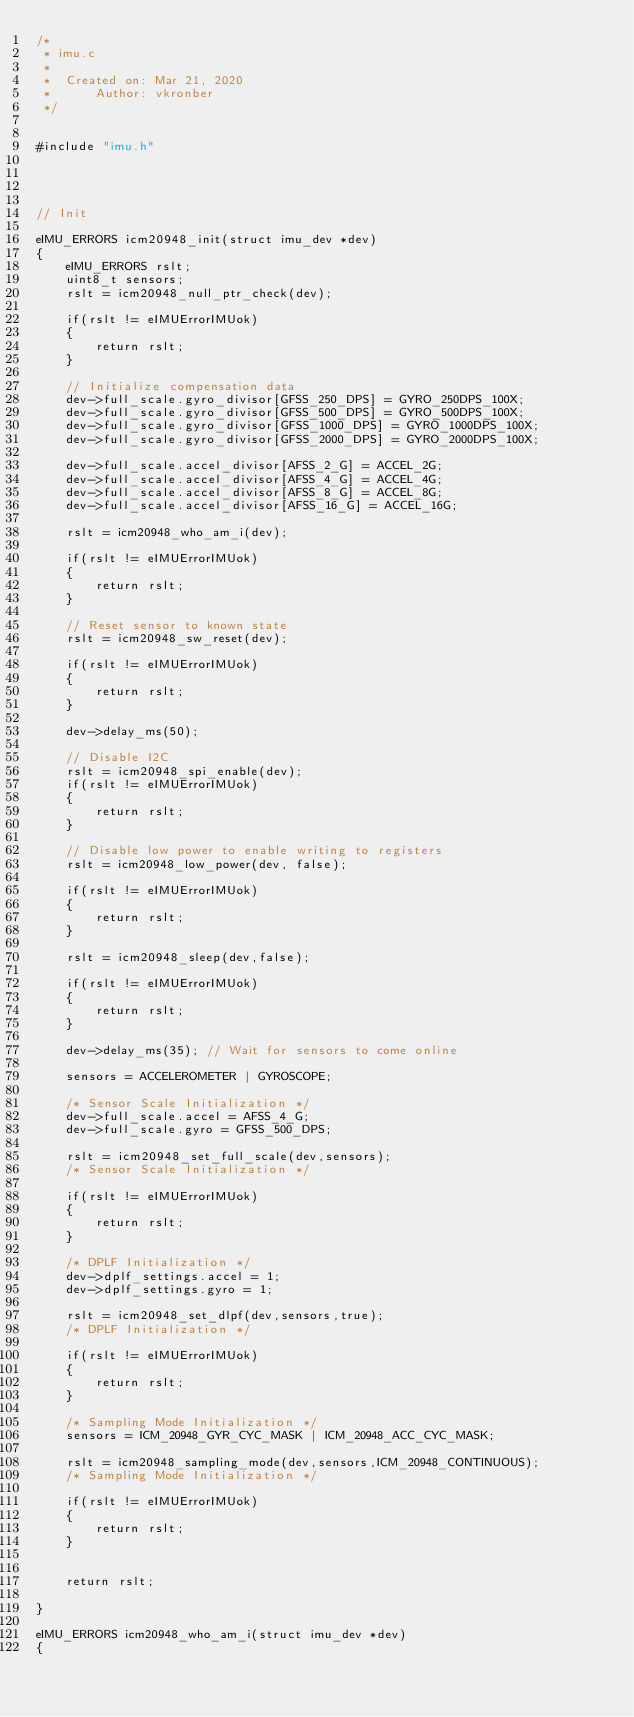Convert code to text. <code><loc_0><loc_0><loc_500><loc_500><_C_>/*
 * imu.c
 *
 *  Created on: Mar 21, 2020
 *      Author: vkronber
 */


#include "imu.h"




// Init

eIMU_ERRORS icm20948_init(struct imu_dev *dev)
{
	eIMU_ERRORS rslt;
	uint8_t sensors;
	rslt = icm20948_null_ptr_check(dev);

	if(rslt != eIMUErrorIMUok)
	{
		return rslt;
	}

	// Initialize compensation data
	dev->full_scale.gyro_divisor[GFSS_250_DPS] = GYRO_250DPS_100X;
	dev->full_scale.gyro_divisor[GFSS_500_DPS] = GYRO_500DPS_100X;
	dev->full_scale.gyro_divisor[GFSS_1000_DPS] = GYRO_1000DPS_100X;
	dev->full_scale.gyro_divisor[GFSS_2000_DPS] = GYRO_2000DPS_100X;

	dev->full_scale.accel_divisor[AFSS_2_G] = ACCEL_2G;
	dev->full_scale.accel_divisor[AFSS_4_G] = ACCEL_4G;
	dev->full_scale.accel_divisor[AFSS_8_G] = ACCEL_8G;
	dev->full_scale.accel_divisor[AFSS_16_G] = ACCEL_16G;

	rslt = icm20948_who_am_i(dev);

	if(rslt != eIMUErrorIMUok)
	{
		return rslt;
	}

	// Reset sensor to known state
	rslt = icm20948_sw_reset(dev);

	if(rslt != eIMUErrorIMUok)
	{
		return rslt;
	}

	dev->delay_ms(50);

	// Disable I2C
	rslt = icm20948_spi_enable(dev);
	if(rslt != eIMUErrorIMUok)
	{
		return rslt;
	}

	// Disable low power to enable writing to registers
	rslt = icm20948_low_power(dev, false);

	if(rslt != eIMUErrorIMUok)
	{
		return rslt;
	}

	rslt = icm20948_sleep(dev,false);

	if(rslt != eIMUErrorIMUok)
	{
		return rslt;
	}

	dev->delay_ms(35); // Wait for sensors to come online

	sensors = ACCELEROMETER | GYROSCOPE;

	/* Sensor Scale Initialization */
	dev->full_scale.accel = AFSS_4_G;
	dev->full_scale.gyro = GFSS_500_DPS;

	rslt = icm20948_set_full_scale(dev,sensors);
	/* Sensor Scale Initialization */

	if(rslt != eIMUErrorIMUok)
	{
		return rslt;
	}

	/* DPLF Initialization */
	dev->dplf_settings.accel = 1;
	dev->dplf_settings.gyro = 1;

	rslt = icm20948_set_dlpf(dev,sensors,true);
	/* DPLF Initialization */

	if(rslt != eIMUErrorIMUok)
	{
		return rslt;
	}

	/* Sampling Mode Initialization */
	sensors = ICM_20948_GYR_CYC_MASK | ICM_20948_ACC_CYC_MASK;

	rslt = icm20948_sampling_mode(dev,sensors,ICM_20948_CONTINUOUS);
	/* Sampling Mode Initialization */

	if(rslt != eIMUErrorIMUok)
	{
		return rslt;
	}


	return rslt;

}

eIMU_ERRORS icm20948_who_am_i(struct imu_dev *dev)
{</code> 